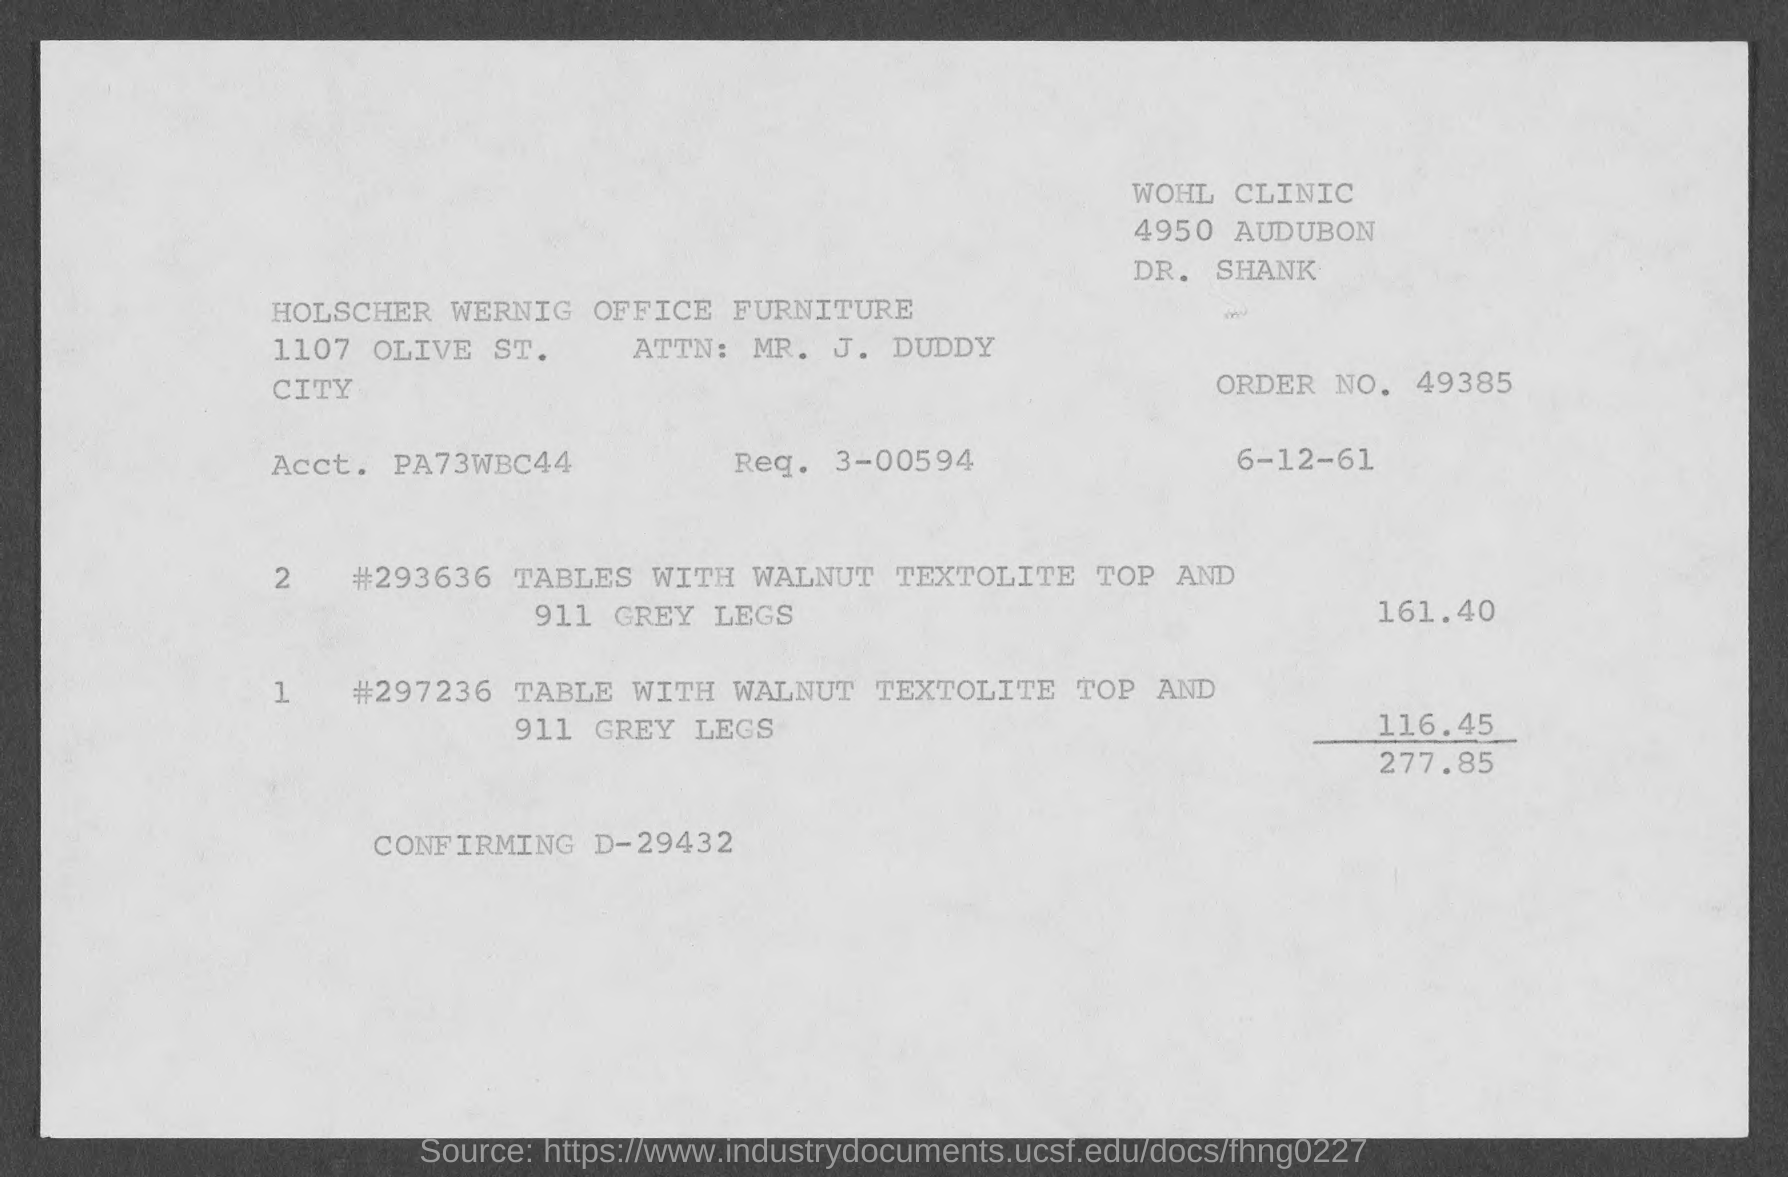Outline some significant characteristics in this image. The request number listed on the invoice is 3-00594... The order number given on the invoice is 49385. The total invoice amount in the document is 277.85. 